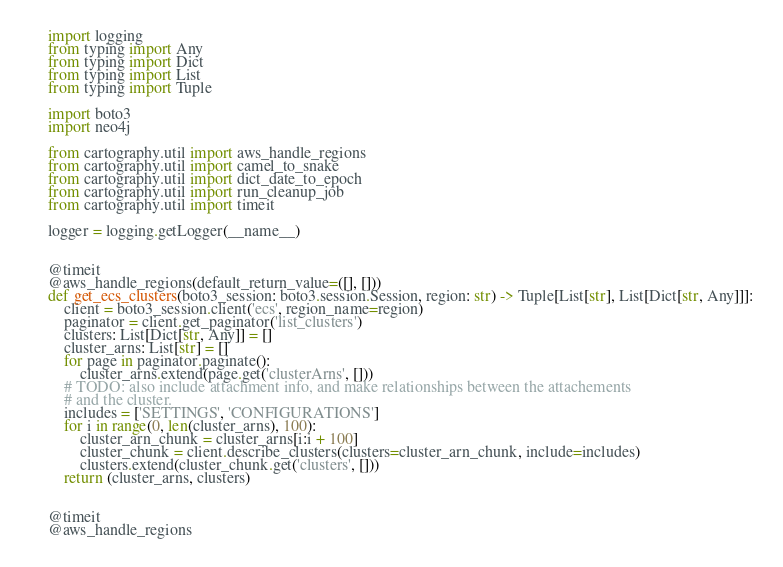<code> <loc_0><loc_0><loc_500><loc_500><_Python_>import logging
from typing import Any
from typing import Dict
from typing import List
from typing import Tuple

import boto3
import neo4j

from cartography.util import aws_handle_regions
from cartography.util import camel_to_snake
from cartography.util import dict_date_to_epoch
from cartography.util import run_cleanup_job
from cartography.util import timeit

logger = logging.getLogger(__name__)


@timeit
@aws_handle_regions(default_return_value=([], []))
def get_ecs_clusters(boto3_session: boto3.session.Session, region: str) -> Tuple[List[str], List[Dict[str, Any]]]:
    client = boto3_session.client('ecs', region_name=region)
    paginator = client.get_paginator('list_clusters')
    clusters: List[Dict[str, Any]] = []
    cluster_arns: List[str] = []
    for page in paginator.paginate():
        cluster_arns.extend(page.get('clusterArns', []))
    # TODO: also include attachment info, and make relationships between the attachements
    # and the cluster.
    includes = ['SETTINGS', 'CONFIGURATIONS']
    for i in range(0, len(cluster_arns), 100):
        cluster_arn_chunk = cluster_arns[i:i + 100]
        cluster_chunk = client.describe_clusters(clusters=cluster_arn_chunk, include=includes)
        clusters.extend(cluster_chunk.get('clusters', []))
    return (cluster_arns, clusters)


@timeit
@aws_handle_regions</code> 